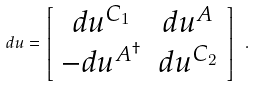Convert formula to latex. <formula><loc_0><loc_0><loc_500><loc_500>d u = \left [ \begin{array} { c c } { { d u ^ { C _ { 1 } } } } & { { d u ^ { A } } } \\ { { - d u ^ { A ^ { \dagger } } } } & { { d u ^ { C _ { 2 } } } } \end{array} \right ] \ .</formula> 